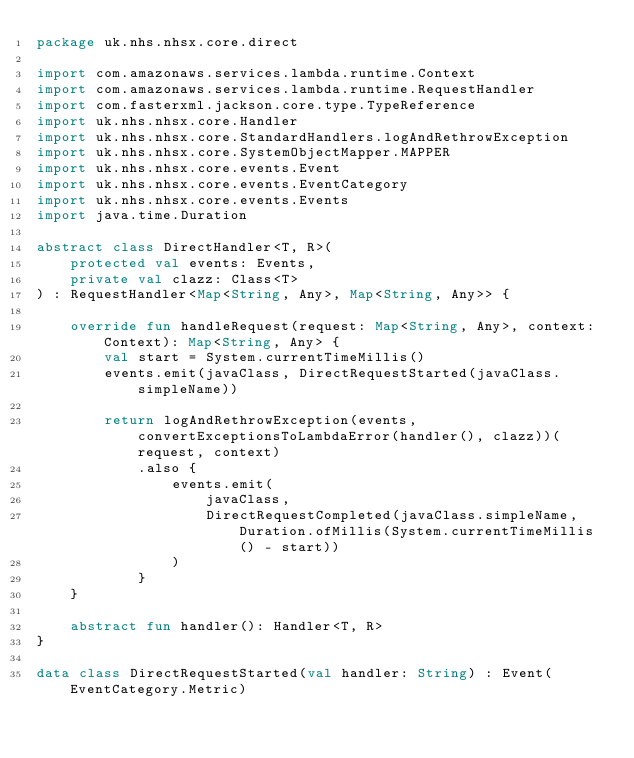Convert code to text. <code><loc_0><loc_0><loc_500><loc_500><_Kotlin_>package uk.nhs.nhsx.core.direct

import com.amazonaws.services.lambda.runtime.Context
import com.amazonaws.services.lambda.runtime.RequestHandler
import com.fasterxml.jackson.core.type.TypeReference
import uk.nhs.nhsx.core.Handler
import uk.nhs.nhsx.core.StandardHandlers.logAndRethrowException
import uk.nhs.nhsx.core.SystemObjectMapper.MAPPER
import uk.nhs.nhsx.core.events.Event
import uk.nhs.nhsx.core.events.EventCategory
import uk.nhs.nhsx.core.events.Events
import java.time.Duration

abstract class DirectHandler<T, R>(
    protected val events: Events,
    private val clazz: Class<T>
) : RequestHandler<Map<String, Any>, Map<String, Any>> {

    override fun handleRequest(request: Map<String, Any>, context: Context): Map<String, Any> {
        val start = System.currentTimeMillis()
        events.emit(javaClass, DirectRequestStarted(javaClass.simpleName))

        return logAndRethrowException(events, convertExceptionsToLambdaError(handler(), clazz))(request, context)
            .also {
                events.emit(
                    javaClass,
                    DirectRequestCompleted(javaClass.simpleName, Duration.ofMillis(System.currentTimeMillis() - start))
                )
            }
    }

    abstract fun handler(): Handler<T, R>
}

data class DirectRequestStarted(val handler: String) : Event(EventCategory.Metric)</code> 